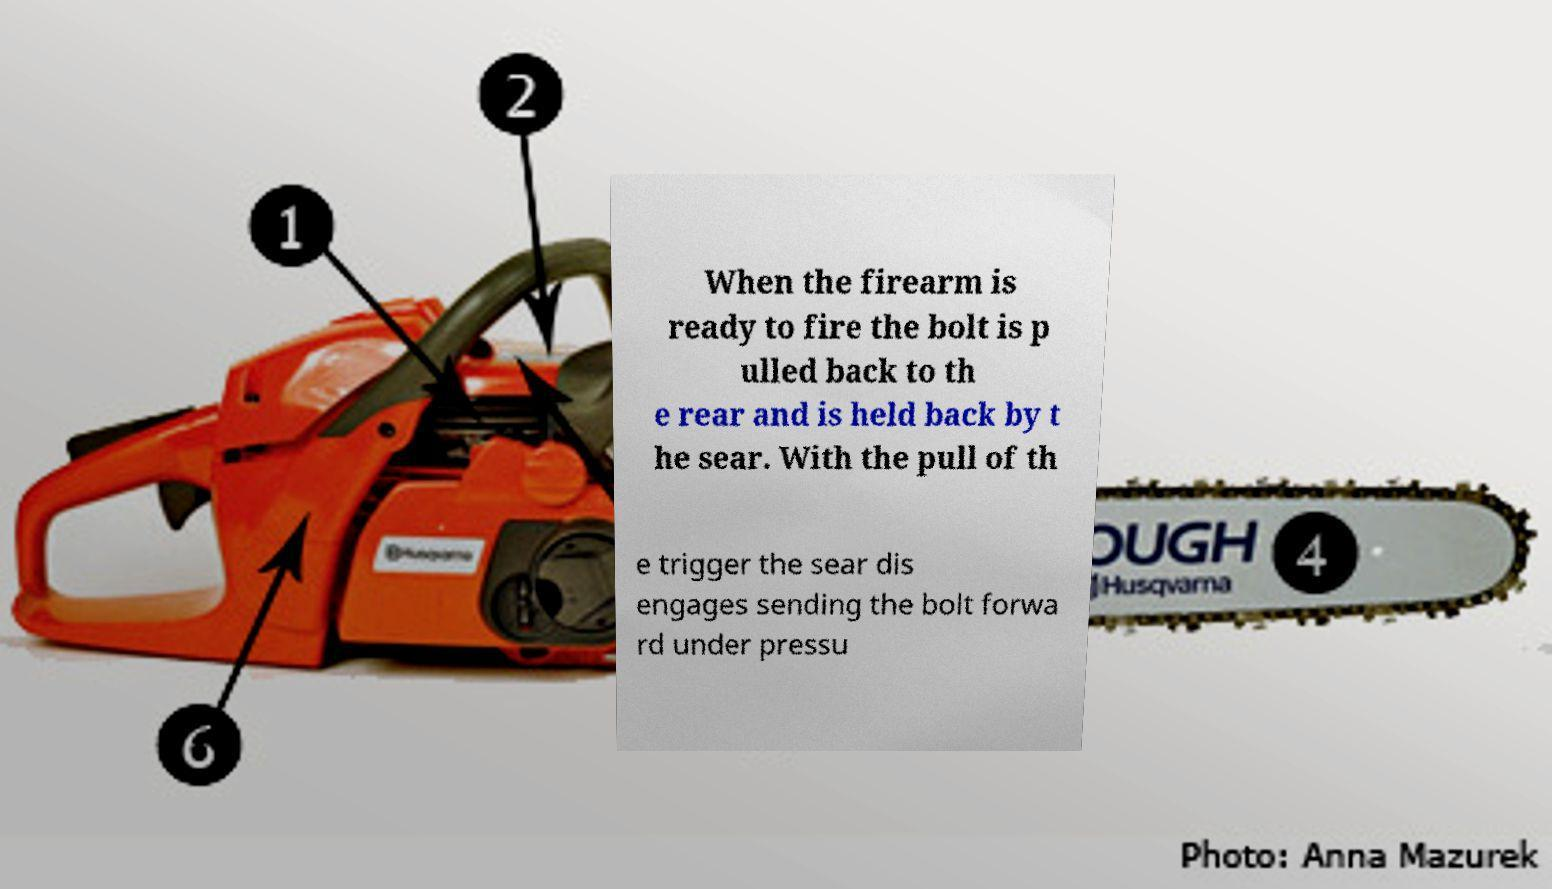Can you read and provide the text displayed in the image?This photo seems to have some interesting text. Can you extract and type it out for me? When the firearm is ready to fire the bolt is p ulled back to th e rear and is held back by t he sear. With the pull of th e trigger the sear dis engages sending the bolt forwa rd under pressu 